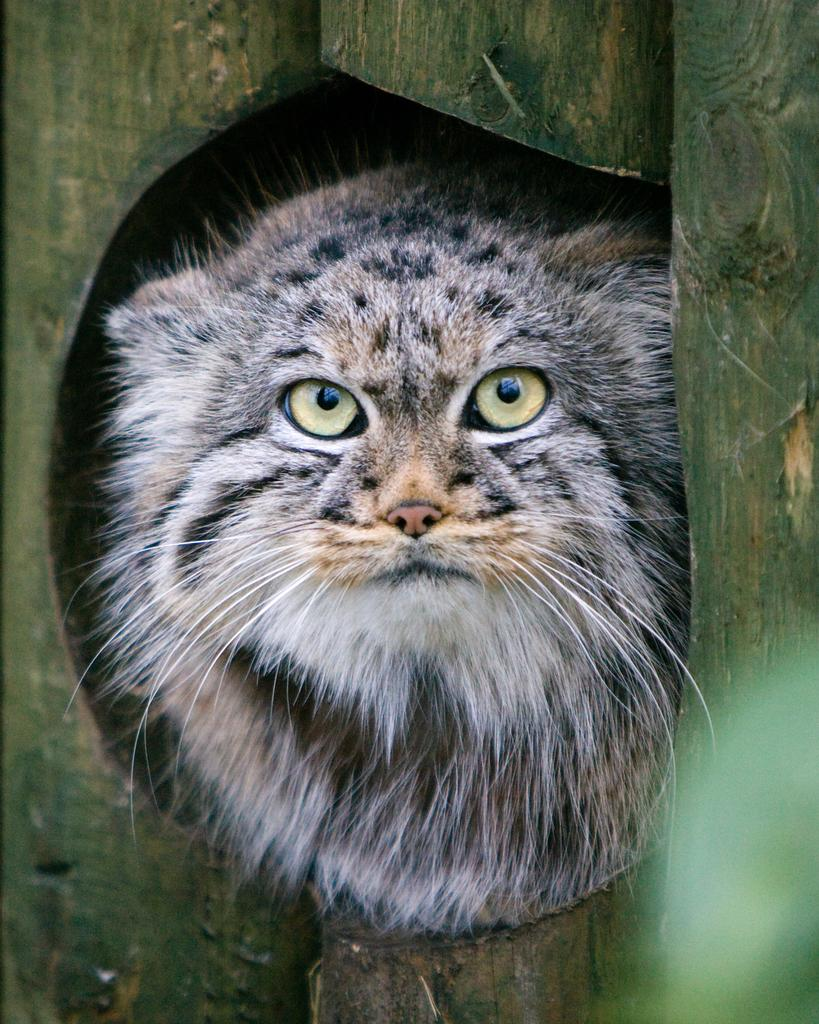What type of animal is in the image? There is a cat in the image. What is surrounding the cat in the image? There are bamboo sticks around the cat. How much profit did the cat make during the rainstorm in the image? There is no mention of profit or a rainstorm in the image, and the cat's activities are not described. 